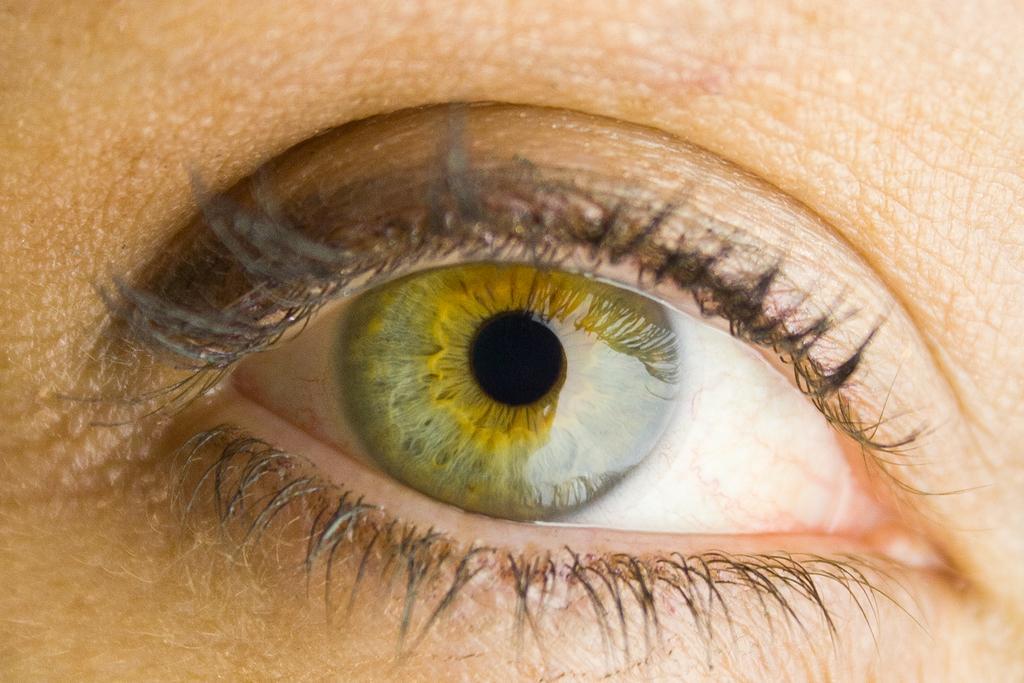How would you summarize this image in a sentence or two? This is a zoomed image. In this image we can see the eye of a person. 